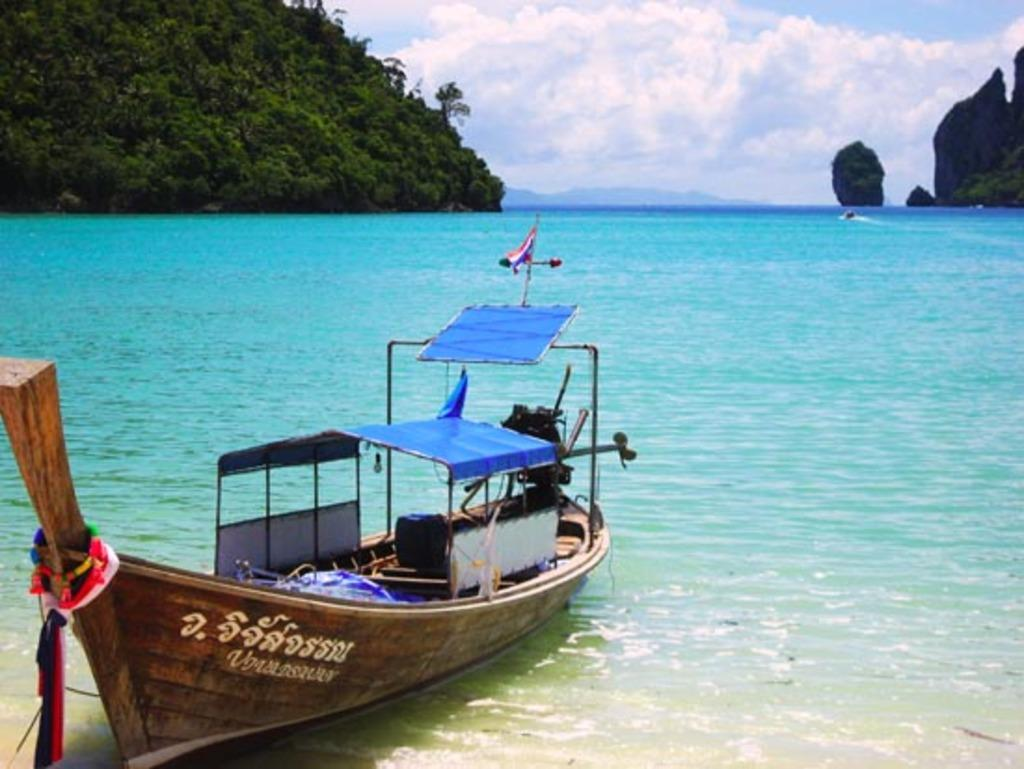What is located on the left side of the image? There is a boat on the water on the left side of the image. What can be seen in the background of the image? There are mountains in the background of the image. What is visible in the sky in the image? There are clouds in the sky. Where is the nest of the bird in the image? There is no bird or nest present in the image. Can you tell me the relationship between the son and the father in the image? There is no son or father present in the image. 